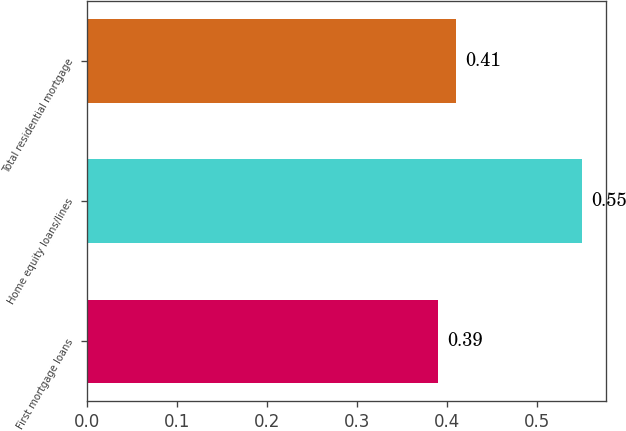Convert chart to OTSL. <chart><loc_0><loc_0><loc_500><loc_500><bar_chart><fcel>First mortgage loans<fcel>Home equity loans/lines<fcel>Total residential mortgage<nl><fcel>0.39<fcel>0.55<fcel>0.41<nl></chart> 